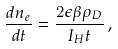<formula> <loc_0><loc_0><loc_500><loc_500>\frac { d n _ { e } } { d t } = \frac { 2 \epsilon \beta \rho _ { D } } { I _ { H } t } \, ,</formula> 